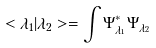Convert formula to latex. <formula><loc_0><loc_0><loc_500><loc_500>< \lambda _ { 1 } | \lambda _ { 2 } > = \int \Psi _ { \lambda _ { 1 } } ^ { * } \Psi _ { \lambda _ { 2 } }</formula> 